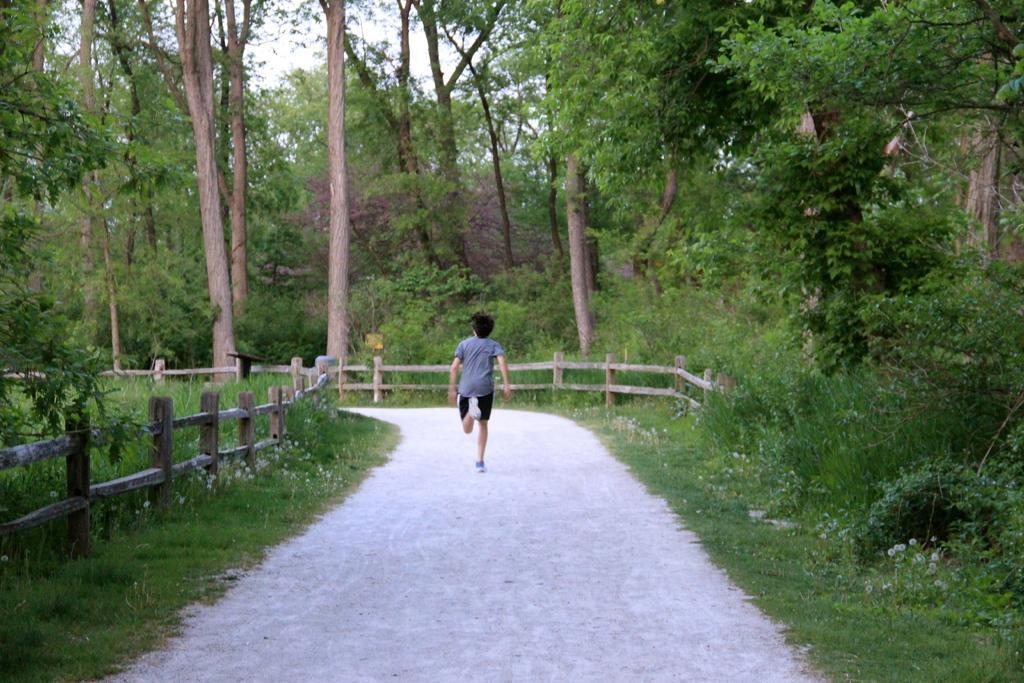Please provide a concise description of this image. In this image, I can see a person running on a pathway. There are trees, plants, grass and wooden fences. In the background there is the sky. 